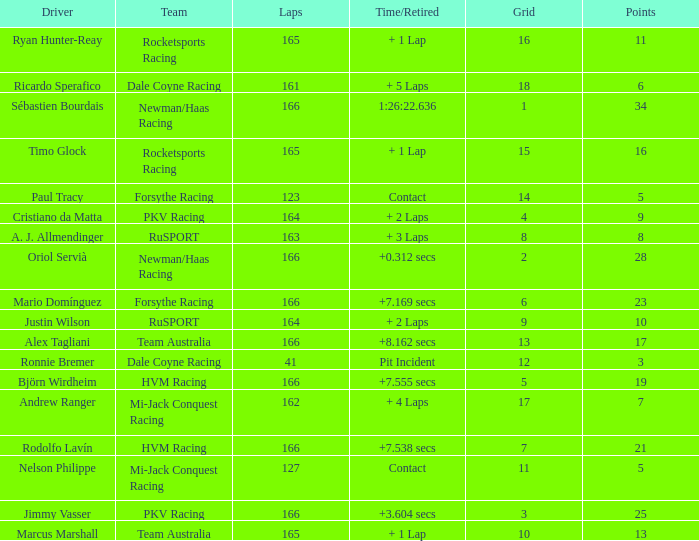What is the name of the driver with 6 points? Ricardo Sperafico. 